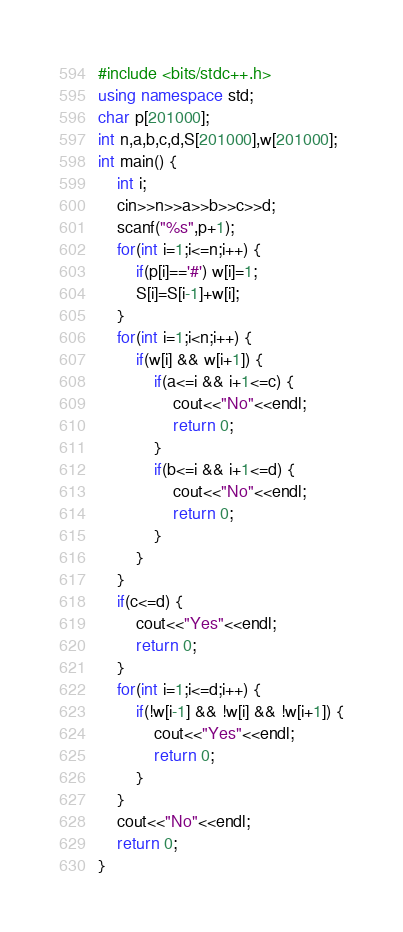<code> <loc_0><loc_0><loc_500><loc_500><_C++_>#include <bits/stdc++.h>
using namespace std;
char p[201000];
int n,a,b,c,d,S[201000],w[201000];
int main() {
	int i;
	cin>>n>>a>>b>>c>>d;
	scanf("%s",p+1);
	for(int i=1;i<=n;i++) {
		if(p[i]=='#') w[i]=1;
		S[i]=S[i-1]+w[i];
	}
	for(int i=1;i<n;i++) {
		if(w[i] && w[i+1]) {
			if(a<=i && i+1<=c) {
				cout<<"No"<<endl;
				return 0;
			}
			if(b<=i && i+1<=d) {
				cout<<"No"<<endl;
				return 0;
			}
		}
	}
	if(c<=d) {
		cout<<"Yes"<<endl;
		return 0;
	}
	for(int i=1;i<=d;i++) {
		if(!w[i-1] && !w[i] && !w[i+1]) {
			cout<<"Yes"<<endl;
			return 0;
		}
	}
	cout<<"No"<<endl;
	return 0;
}</code> 